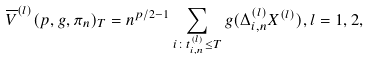<formula> <loc_0><loc_0><loc_500><loc_500>\overline { V } ^ { ( l ) } ( p , g , \pi _ { n } ) _ { T } = n ^ { p / 2 - 1 } \sum _ { i \colon t _ { i , n } ^ { ( l ) } \leq T } g ( \Delta _ { i , n } ^ { ( l ) } X ^ { ( l ) } ) , l = 1 , 2 ,</formula> 